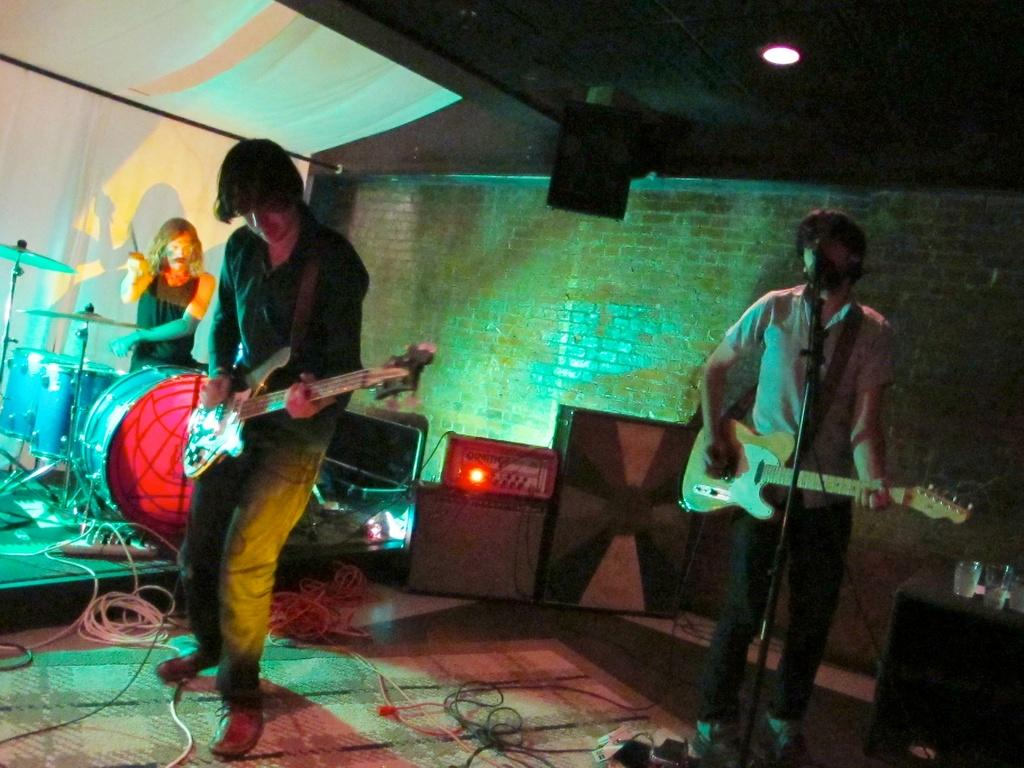How many people are present in the image? There are three people in the image. What are two of the people holding in the image? Two of the people are holding guitars. What is the third person doing in the image? The third person is playing musical drums. What type of needle is being used to expand the drum in the image? There is no needle or expansion of the drum visible in the image. What happens to the guitars when the drums are smashed in the image? There is no smashing of drums or any impact on the guitars in the image. 